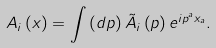Convert formula to latex. <formula><loc_0><loc_0><loc_500><loc_500>A _ { i } \left ( x \right ) = \int \left ( d p \right ) \tilde { A } _ { i } \left ( p \right ) e ^ { i p ^ { a } x _ { a } } .</formula> 